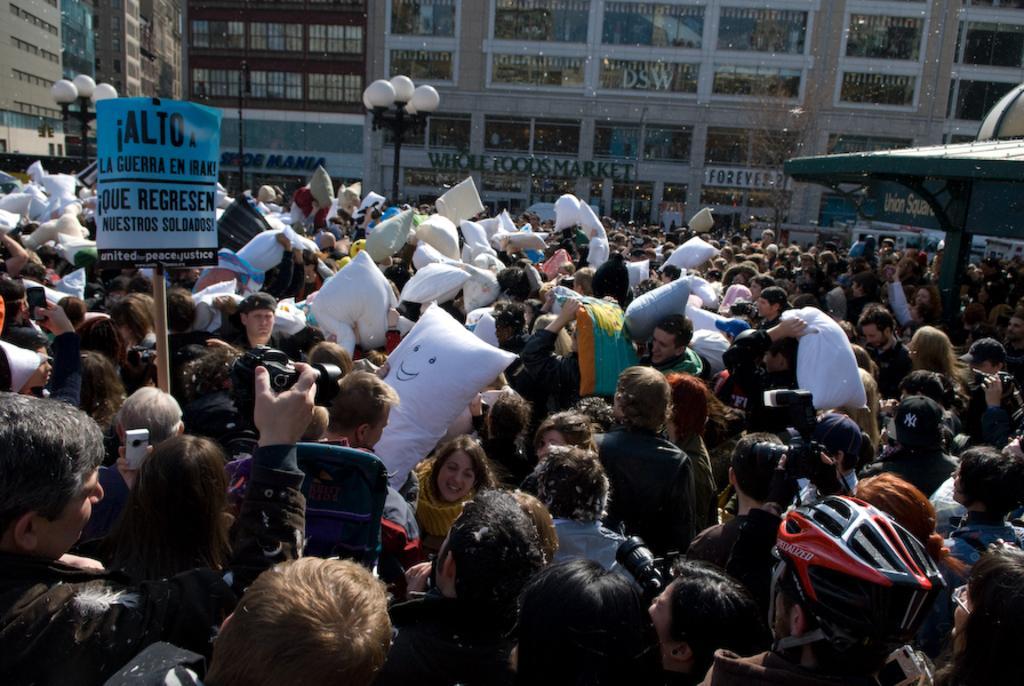Describe this image in one or two sentences. In this picture we can see many people are standing and holding objects in their hands. There are few street lights and some buildings in the background. 